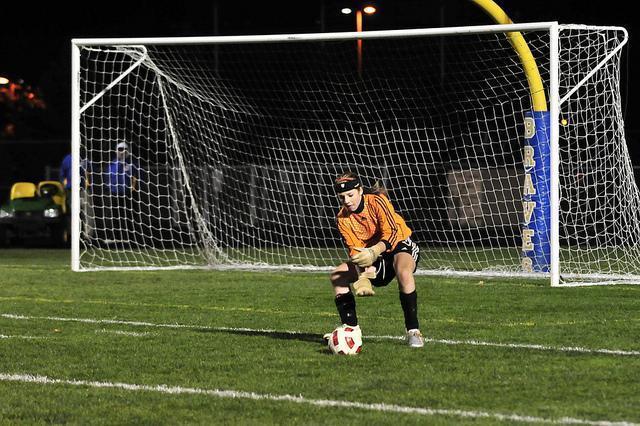How many people are visible?
Give a very brief answer. 2. How many chairs are near the patio table?
Give a very brief answer. 0. 